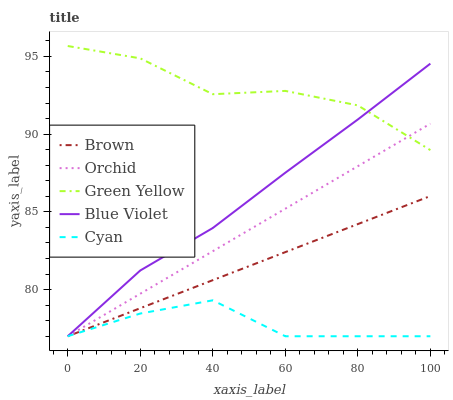Does Cyan have the minimum area under the curve?
Answer yes or no. Yes. Does Green Yellow have the maximum area under the curve?
Answer yes or no. Yes. Does Green Yellow have the minimum area under the curve?
Answer yes or no. No. Does Cyan have the maximum area under the curve?
Answer yes or no. No. Is Orchid the smoothest?
Answer yes or no. Yes. Is Green Yellow the roughest?
Answer yes or no. Yes. Is Cyan the smoothest?
Answer yes or no. No. Is Cyan the roughest?
Answer yes or no. No. Does Brown have the lowest value?
Answer yes or no. Yes. Does Green Yellow have the lowest value?
Answer yes or no. No. Does Green Yellow have the highest value?
Answer yes or no. Yes. Does Cyan have the highest value?
Answer yes or no. No. Is Brown less than Green Yellow?
Answer yes or no. Yes. Is Green Yellow greater than Cyan?
Answer yes or no. Yes. Does Orchid intersect Blue Violet?
Answer yes or no. Yes. Is Orchid less than Blue Violet?
Answer yes or no. No. Is Orchid greater than Blue Violet?
Answer yes or no. No. Does Brown intersect Green Yellow?
Answer yes or no. No. 